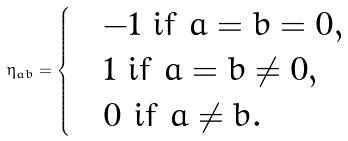<formula> <loc_0><loc_0><loc_500><loc_500>\eta _ { a b } = \begin{cases} & - 1 \text {  if $a=b=0$} , \\ & 1 \text {  if $a=b\neq 0$} , \\ & 0 \text {  if $a \neq b$} . \end{cases}</formula> 